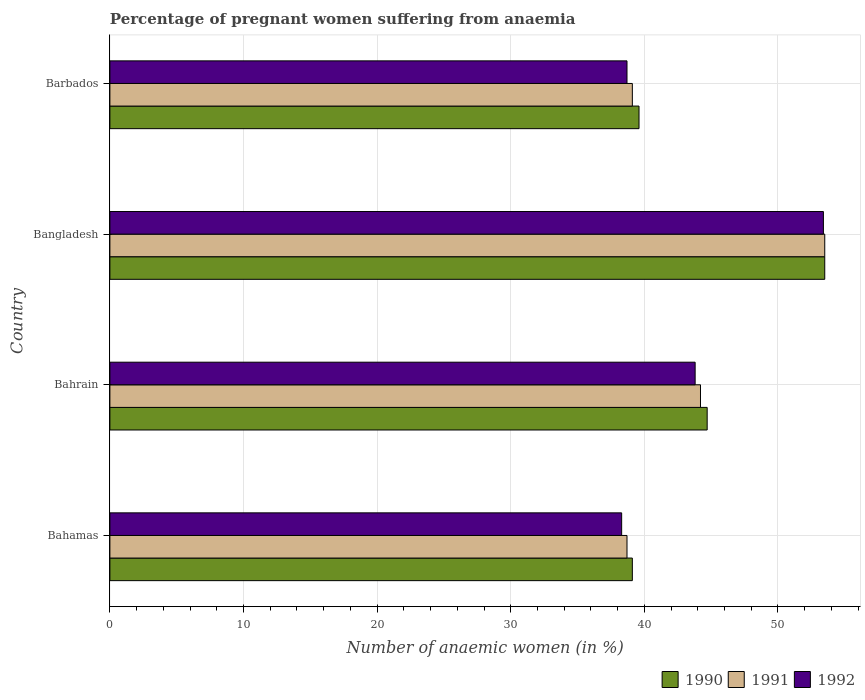Are the number of bars per tick equal to the number of legend labels?
Offer a terse response. Yes. Are the number of bars on each tick of the Y-axis equal?
Keep it short and to the point. Yes. How many bars are there on the 4th tick from the top?
Your response must be concise. 3. How many bars are there on the 3rd tick from the bottom?
Give a very brief answer. 3. What is the label of the 1st group of bars from the top?
Make the answer very short. Barbados. In how many cases, is the number of bars for a given country not equal to the number of legend labels?
Your answer should be compact. 0. What is the number of anaemic women in 1991 in Bangladesh?
Offer a terse response. 53.5. Across all countries, what is the maximum number of anaemic women in 1992?
Keep it short and to the point. 53.4. Across all countries, what is the minimum number of anaemic women in 1991?
Ensure brevity in your answer.  38.7. In which country was the number of anaemic women in 1991 minimum?
Make the answer very short. Bahamas. What is the total number of anaemic women in 1990 in the graph?
Ensure brevity in your answer.  176.9. What is the difference between the number of anaemic women in 1990 in Bahamas and that in Barbados?
Your response must be concise. -0.5. What is the difference between the number of anaemic women in 1990 in Bahamas and the number of anaemic women in 1991 in Barbados?
Keep it short and to the point. 0. What is the average number of anaemic women in 1991 per country?
Offer a terse response. 43.88. What is the difference between the number of anaemic women in 1991 and number of anaemic women in 1990 in Bahrain?
Ensure brevity in your answer.  -0.5. In how many countries, is the number of anaemic women in 1991 greater than 18 %?
Offer a terse response. 4. What is the ratio of the number of anaemic women in 1991 in Bahrain to that in Barbados?
Make the answer very short. 1.13. What is the difference between the highest and the second highest number of anaemic women in 1991?
Keep it short and to the point. 9.3. What is the difference between the highest and the lowest number of anaemic women in 1990?
Your answer should be very brief. 14.4. Is it the case that in every country, the sum of the number of anaemic women in 1992 and number of anaemic women in 1990 is greater than the number of anaemic women in 1991?
Your answer should be compact. Yes. How many countries are there in the graph?
Ensure brevity in your answer.  4. What is the difference between two consecutive major ticks on the X-axis?
Give a very brief answer. 10. Does the graph contain any zero values?
Keep it short and to the point. No. Does the graph contain grids?
Give a very brief answer. Yes. Where does the legend appear in the graph?
Your answer should be very brief. Bottom right. How are the legend labels stacked?
Provide a succinct answer. Horizontal. What is the title of the graph?
Keep it short and to the point. Percentage of pregnant women suffering from anaemia. Does "2013" appear as one of the legend labels in the graph?
Offer a very short reply. No. What is the label or title of the X-axis?
Ensure brevity in your answer.  Number of anaemic women (in %). What is the Number of anaemic women (in %) in 1990 in Bahamas?
Ensure brevity in your answer.  39.1. What is the Number of anaemic women (in %) of 1991 in Bahamas?
Keep it short and to the point. 38.7. What is the Number of anaemic women (in %) in 1992 in Bahamas?
Ensure brevity in your answer.  38.3. What is the Number of anaemic women (in %) in 1990 in Bahrain?
Keep it short and to the point. 44.7. What is the Number of anaemic women (in %) in 1991 in Bahrain?
Give a very brief answer. 44.2. What is the Number of anaemic women (in %) in 1992 in Bahrain?
Keep it short and to the point. 43.8. What is the Number of anaemic women (in %) of 1990 in Bangladesh?
Offer a terse response. 53.5. What is the Number of anaemic women (in %) of 1991 in Bangladesh?
Provide a succinct answer. 53.5. What is the Number of anaemic women (in %) in 1992 in Bangladesh?
Your answer should be very brief. 53.4. What is the Number of anaemic women (in %) in 1990 in Barbados?
Ensure brevity in your answer.  39.6. What is the Number of anaemic women (in %) of 1991 in Barbados?
Keep it short and to the point. 39.1. What is the Number of anaemic women (in %) in 1992 in Barbados?
Your answer should be compact. 38.7. Across all countries, what is the maximum Number of anaemic women (in %) of 1990?
Your response must be concise. 53.5. Across all countries, what is the maximum Number of anaemic women (in %) of 1991?
Provide a succinct answer. 53.5. Across all countries, what is the maximum Number of anaemic women (in %) of 1992?
Your response must be concise. 53.4. Across all countries, what is the minimum Number of anaemic women (in %) in 1990?
Provide a succinct answer. 39.1. Across all countries, what is the minimum Number of anaemic women (in %) in 1991?
Give a very brief answer. 38.7. Across all countries, what is the minimum Number of anaemic women (in %) in 1992?
Ensure brevity in your answer.  38.3. What is the total Number of anaemic women (in %) of 1990 in the graph?
Offer a terse response. 176.9. What is the total Number of anaemic women (in %) in 1991 in the graph?
Your response must be concise. 175.5. What is the total Number of anaemic women (in %) in 1992 in the graph?
Provide a succinct answer. 174.2. What is the difference between the Number of anaemic women (in %) in 1991 in Bahamas and that in Bahrain?
Ensure brevity in your answer.  -5.5. What is the difference between the Number of anaemic women (in %) in 1990 in Bahamas and that in Bangladesh?
Offer a terse response. -14.4. What is the difference between the Number of anaemic women (in %) in 1991 in Bahamas and that in Bangladesh?
Ensure brevity in your answer.  -14.8. What is the difference between the Number of anaemic women (in %) in 1992 in Bahamas and that in Bangladesh?
Your answer should be compact. -15.1. What is the difference between the Number of anaemic women (in %) in 1990 in Bahamas and that in Barbados?
Make the answer very short. -0.5. What is the difference between the Number of anaemic women (in %) of 1992 in Bahamas and that in Barbados?
Provide a succinct answer. -0.4. What is the difference between the Number of anaemic women (in %) in 1990 in Bahrain and that in Bangladesh?
Keep it short and to the point. -8.8. What is the difference between the Number of anaemic women (in %) of 1991 in Bahrain and that in Bangladesh?
Make the answer very short. -9.3. What is the difference between the Number of anaemic women (in %) in 1991 in Bahrain and that in Barbados?
Make the answer very short. 5.1. What is the difference between the Number of anaemic women (in %) of 1992 in Bahrain and that in Barbados?
Give a very brief answer. 5.1. What is the difference between the Number of anaemic women (in %) in 1990 in Bangladesh and that in Barbados?
Offer a terse response. 13.9. What is the difference between the Number of anaemic women (in %) in 1992 in Bangladesh and that in Barbados?
Offer a terse response. 14.7. What is the difference between the Number of anaemic women (in %) in 1990 in Bahamas and the Number of anaemic women (in %) in 1991 in Bahrain?
Give a very brief answer. -5.1. What is the difference between the Number of anaemic women (in %) in 1990 in Bahamas and the Number of anaemic women (in %) in 1991 in Bangladesh?
Offer a terse response. -14.4. What is the difference between the Number of anaemic women (in %) of 1990 in Bahamas and the Number of anaemic women (in %) of 1992 in Bangladesh?
Your answer should be very brief. -14.3. What is the difference between the Number of anaemic women (in %) of 1991 in Bahamas and the Number of anaemic women (in %) of 1992 in Bangladesh?
Provide a short and direct response. -14.7. What is the difference between the Number of anaemic women (in %) in 1991 in Bahrain and the Number of anaemic women (in %) in 1992 in Bangladesh?
Offer a very short reply. -9.2. What is the difference between the Number of anaemic women (in %) in 1990 in Bahrain and the Number of anaemic women (in %) in 1992 in Barbados?
Provide a short and direct response. 6. What is the difference between the Number of anaemic women (in %) in 1990 in Bangladesh and the Number of anaemic women (in %) in 1992 in Barbados?
Your answer should be very brief. 14.8. What is the difference between the Number of anaemic women (in %) of 1991 in Bangladesh and the Number of anaemic women (in %) of 1992 in Barbados?
Make the answer very short. 14.8. What is the average Number of anaemic women (in %) of 1990 per country?
Make the answer very short. 44.23. What is the average Number of anaemic women (in %) of 1991 per country?
Offer a terse response. 43.88. What is the average Number of anaemic women (in %) of 1992 per country?
Ensure brevity in your answer.  43.55. What is the difference between the Number of anaemic women (in %) in 1990 and Number of anaemic women (in %) in 1991 in Bahamas?
Your answer should be compact. 0.4. What is the difference between the Number of anaemic women (in %) of 1991 and Number of anaemic women (in %) of 1992 in Bahamas?
Keep it short and to the point. 0.4. What is the difference between the Number of anaemic women (in %) of 1990 and Number of anaemic women (in %) of 1992 in Bahrain?
Your answer should be compact. 0.9. What is the difference between the Number of anaemic women (in %) in 1991 and Number of anaemic women (in %) in 1992 in Bahrain?
Keep it short and to the point. 0.4. What is the difference between the Number of anaemic women (in %) in 1990 and Number of anaemic women (in %) in 1992 in Bangladesh?
Give a very brief answer. 0.1. What is the difference between the Number of anaemic women (in %) of 1990 and Number of anaemic women (in %) of 1991 in Barbados?
Ensure brevity in your answer.  0.5. What is the difference between the Number of anaemic women (in %) of 1990 and Number of anaemic women (in %) of 1992 in Barbados?
Ensure brevity in your answer.  0.9. What is the difference between the Number of anaemic women (in %) of 1991 and Number of anaemic women (in %) of 1992 in Barbados?
Keep it short and to the point. 0.4. What is the ratio of the Number of anaemic women (in %) of 1990 in Bahamas to that in Bahrain?
Your response must be concise. 0.87. What is the ratio of the Number of anaemic women (in %) of 1991 in Bahamas to that in Bahrain?
Provide a short and direct response. 0.88. What is the ratio of the Number of anaemic women (in %) in 1992 in Bahamas to that in Bahrain?
Keep it short and to the point. 0.87. What is the ratio of the Number of anaemic women (in %) of 1990 in Bahamas to that in Bangladesh?
Provide a short and direct response. 0.73. What is the ratio of the Number of anaemic women (in %) in 1991 in Bahamas to that in Bangladesh?
Make the answer very short. 0.72. What is the ratio of the Number of anaemic women (in %) of 1992 in Bahamas to that in Bangladesh?
Keep it short and to the point. 0.72. What is the ratio of the Number of anaemic women (in %) in 1990 in Bahamas to that in Barbados?
Ensure brevity in your answer.  0.99. What is the ratio of the Number of anaemic women (in %) in 1990 in Bahrain to that in Bangladesh?
Your answer should be compact. 0.84. What is the ratio of the Number of anaemic women (in %) in 1991 in Bahrain to that in Bangladesh?
Offer a terse response. 0.83. What is the ratio of the Number of anaemic women (in %) in 1992 in Bahrain to that in Bangladesh?
Offer a terse response. 0.82. What is the ratio of the Number of anaemic women (in %) of 1990 in Bahrain to that in Barbados?
Make the answer very short. 1.13. What is the ratio of the Number of anaemic women (in %) in 1991 in Bahrain to that in Barbados?
Provide a short and direct response. 1.13. What is the ratio of the Number of anaemic women (in %) in 1992 in Bahrain to that in Barbados?
Provide a short and direct response. 1.13. What is the ratio of the Number of anaemic women (in %) of 1990 in Bangladesh to that in Barbados?
Offer a very short reply. 1.35. What is the ratio of the Number of anaemic women (in %) of 1991 in Bangladesh to that in Barbados?
Keep it short and to the point. 1.37. What is the ratio of the Number of anaemic women (in %) of 1992 in Bangladesh to that in Barbados?
Keep it short and to the point. 1.38. What is the difference between the highest and the second highest Number of anaemic women (in %) in 1990?
Provide a succinct answer. 8.8. What is the difference between the highest and the second highest Number of anaemic women (in %) of 1992?
Your answer should be very brief. 9.6. 